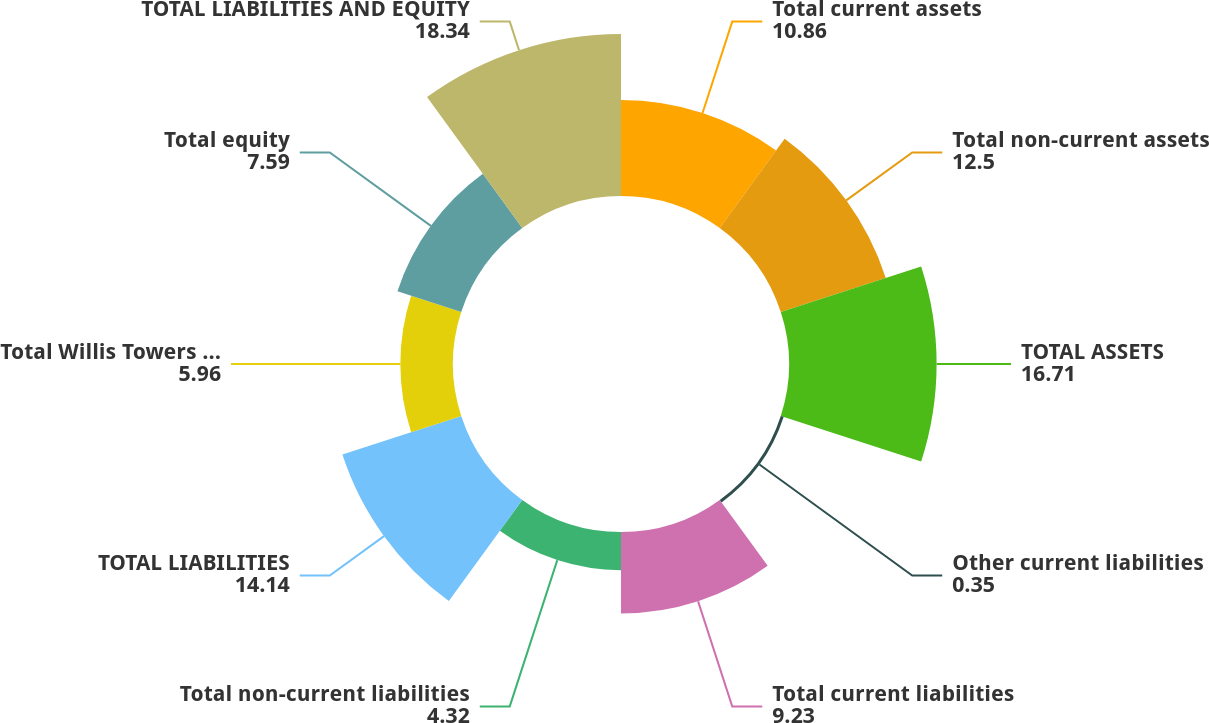Convert chart to OTSL. <chart><loc_0><loc_0><loc_500><loc_500><pie_chart><fcel>Total current assets<fcel>Total non-current assets<fcel>TOTAL ASSETS<fcel>Other current liabilities<fcel>Total current liabilities<fcel>Total non-current liabilities<fcel>TOTAL LIABILITIES<fcel>Total Willis Towers Watson<fcel>Total equity<fcel>TOTAL LIABILITIES AND EQUITY<nl><fcel>10.86%<fcel>12.5%<fcel>16.71%<fcel>0.35%<fcel>9.23%<fcel>4.32%<fcel>14.14%<fcel>5.96%<fcel>7.59%<fcel>18.34%<nl></chart> 